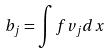Convert formula to latex. <formula><loc_0><loc_0><loc_500><loc_500>b _ { j } = \int f v _ { j } d x</formula> 